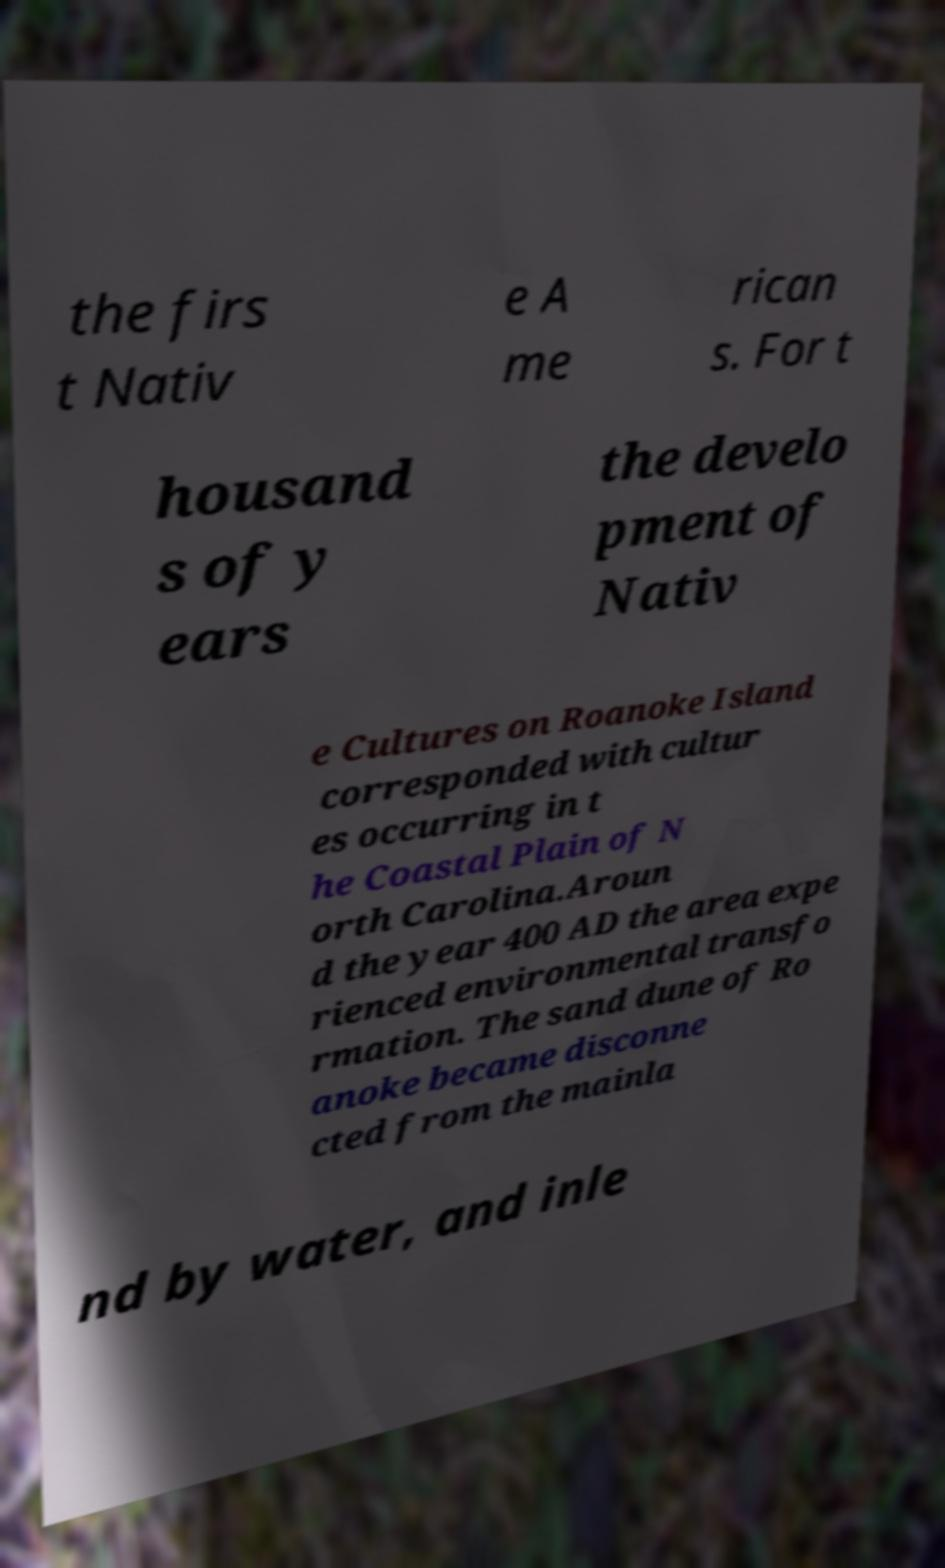There's text embedded in this image that I need extracted. Can you transcribe it verbatim? the firs t Nativ e A me rican s. For t housand s of y ears the develo pment of Nativ e Cultures on Roanoke Island corresponded with cultur es occurring in t he Coastal Plain of N orth Carolina.Aroun d the year 400 AD the area expe rienced environmental transfo rmation. The sand dune of Ro anoke became disconne cted from the mainla nd by water, and inle 